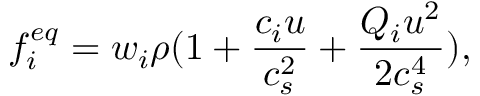<formula> <loc_0><loc_0><loc_500><loc_500>f _ { i } ^ { e q } = w _ { i } \rho ( 1 + \frac { c _ { i } u } { c _ { s } ^ { 2 } } + \frac { Q _ { i } u ^ { 2 } } { 2 c _ { s } ^ { 4 } } ) ,</formula> 